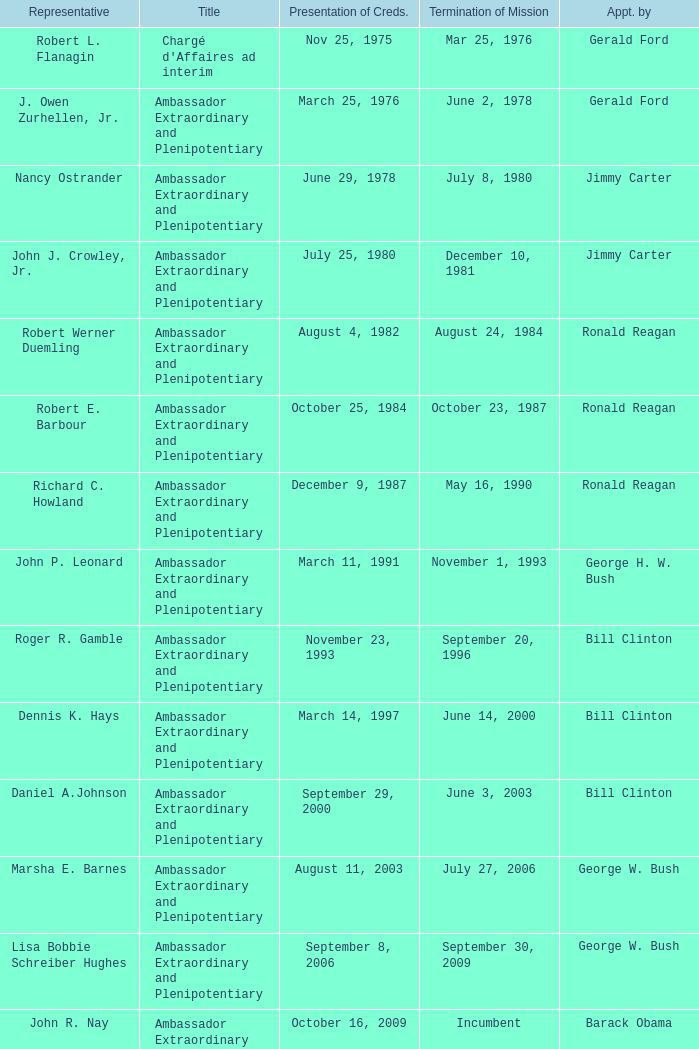What is the Termination of Mission date for Marsha E. Barnes, the Ambassador Extraordinary and Plenipotentiary? July 27, 2006. 